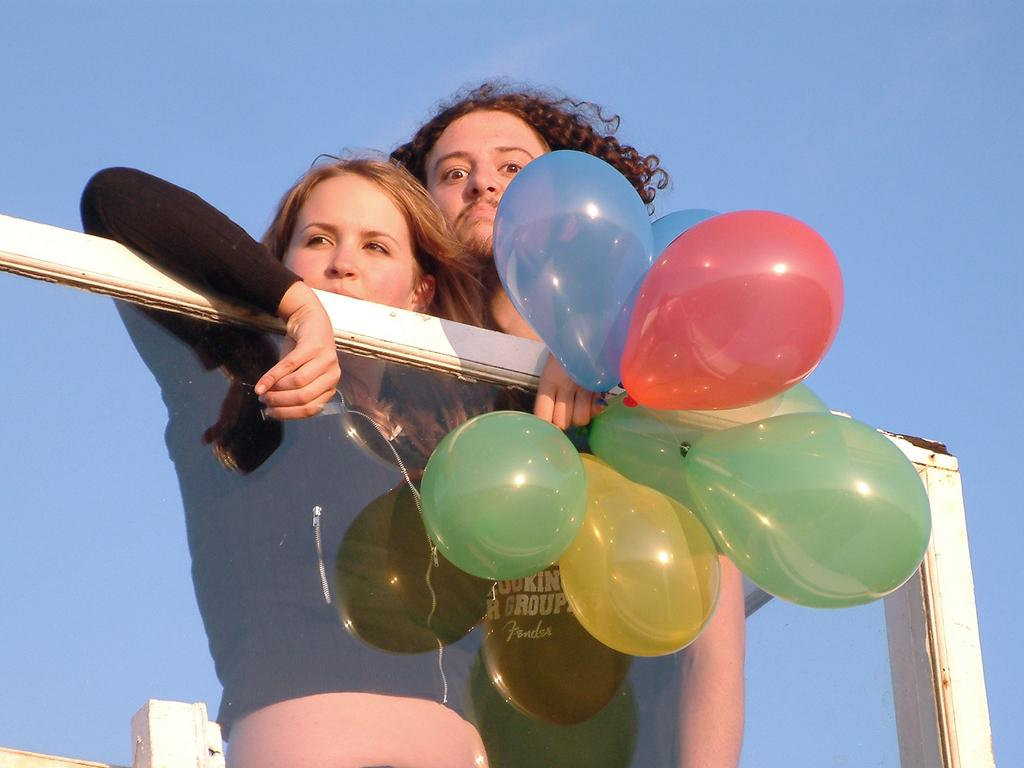How many people are present in the image? There are two people in the image. What else can be seen in the image besides the people? There are balloons, a glass, and some unspecified objects in the image. What is visible in the background of the image? The sky is visible in the background of the image. What letter is being held by one of the people in the image? There is no letter present in the image; only balloons, a glass, and unspecified objects are visible. 